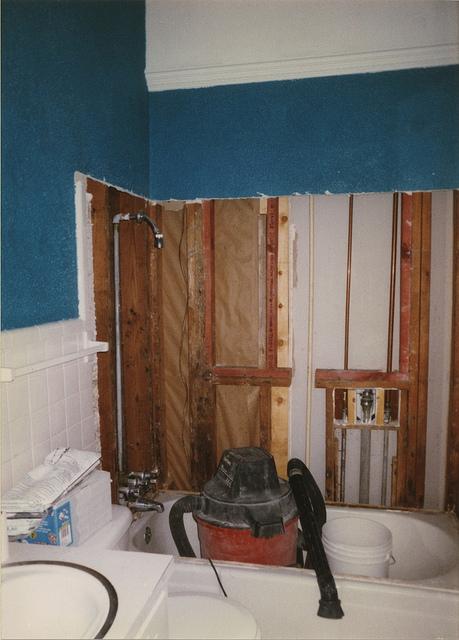When do you think the remodeling will be completed?
Quick response, please. 2 weeks. Is there a bucket in the tub?
Write a very short answer. Yes. Is there a tree in this picture?
Short answer required. No. Who made this room?
Short answer required. Carpenter. 